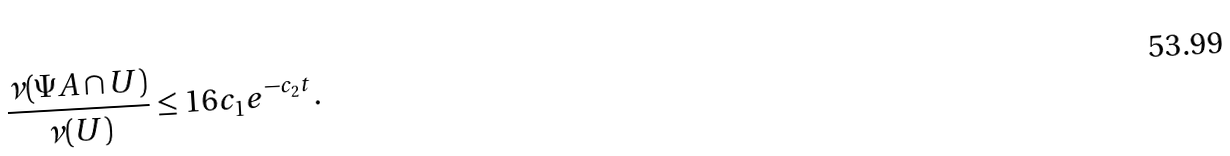<formula> <loc_0><loc_0><loc_500><loc_500>\frac { \nu ( \Psi A \cap U ) } { \nu ( U ) } \leq 1 6 c _ { 1 } e ^ { - c _ { 2 } t } .</formula> 